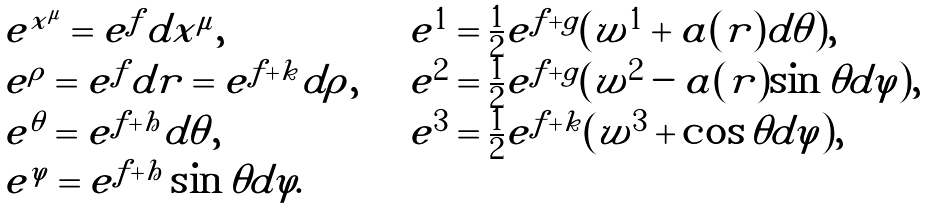Convert formula to latex. <formula><loc_0><loc_0><loc_500><loc_500>\begin{array} { l l } e ^ { x ^ { \mu } } = e ^ { f } d x ^ { \mu } , & e ^ { 1 } = \frac { 1 } { 2 } e ^ { f + g } ( w ^ { 1 } + a ( r ) d \theta ) , \\ e ^ { \rho } = e ^ { f } d r = e ^ { f + k } d \rho , \quad & e ^ { 2 } = \frac { 1 } { 2 } e ^ { f + g } ( w ^ { 2 } - a ( r ) \sin \theta d \varphi ) , \\ e ^ { \theta } = e ^ { f + h } d \theta , & e ^ { 3 } = \frac { 1 } { 2 } e ^ { f + k } ( w ^ { 3 } + \cos \theta d \varphi ) , \\ e ^ { \varphi } = e ^ { f + h } \sin \theta d \varphi . & \end{array}</formula> 